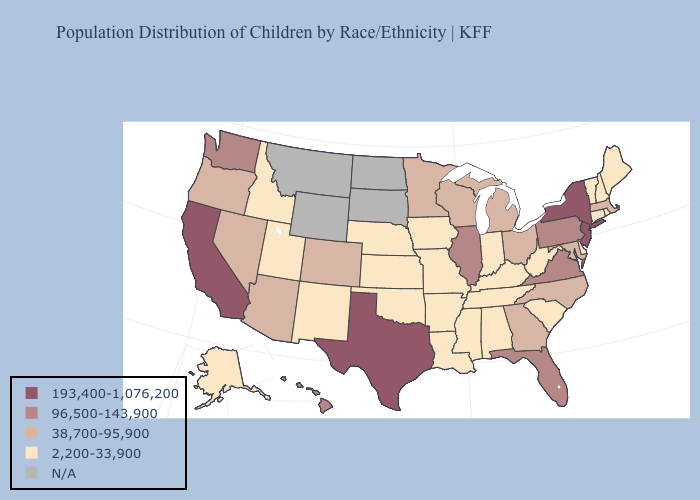Does the first symbol in the legend represent the smallest category?
Short answer required. No. Which states have the highest value in the USA?
Short answer required. California, New Jersey, New York, Texas. What is the lowest value in the USA?
Quick response, please. 2,200-33,900. Name the states that have a value in the range 193,400-1,076,200?
Write a very short answer. California, New Jersey, New York, Texas. Name the states that have a value in the range 2,200-33,900?
Write a very short answer. Alabama, Alaska, Arkansas, Connecticut, Delaware, Idaho, Indiana, Iowa, Kansas, Kentucky, Louisiana, Maine, Mississippi, Missouri, Nebraska, New Hampshire, New Mexico, Oklahoma, Rhode Island, South Carolina, Tennessee, Utah, Vermont, West Virginia. Name the states that have a value in the range N/A?
Concise answer only. Montana, North Dakota, South Dakota, Wyoming. How many symbols are there in the legend?
Give a very brief answer. 5. Name the states that have a value in the range 96,500-143,900?
Be succinct. Florida, Hawaii, Illinois, Pennsylvania, Virginia, Washington. What is the value of Arizona?
Keep it brief. 38,700-95,900. Name the states that have a value in the range 193,400-1,076,200?
Be succinct. California, New Jersey, New York, Texas. Name the states that have a value in the range 96,500-143,900?
Keep it brief. Florida, Hawaii, Illinois, Pennsylvania, Virginia, Washington. What is the lowest value in the Northeast?
Write a very short answer. 2,200-33,900. What is the value of Maine?
Quick response, please. 2,200-33,900. Does California have the highest value in the West?
Keep it brief. Yes. Does the first symbol in the legend represent the smallest category?
Answer briefly. No. 